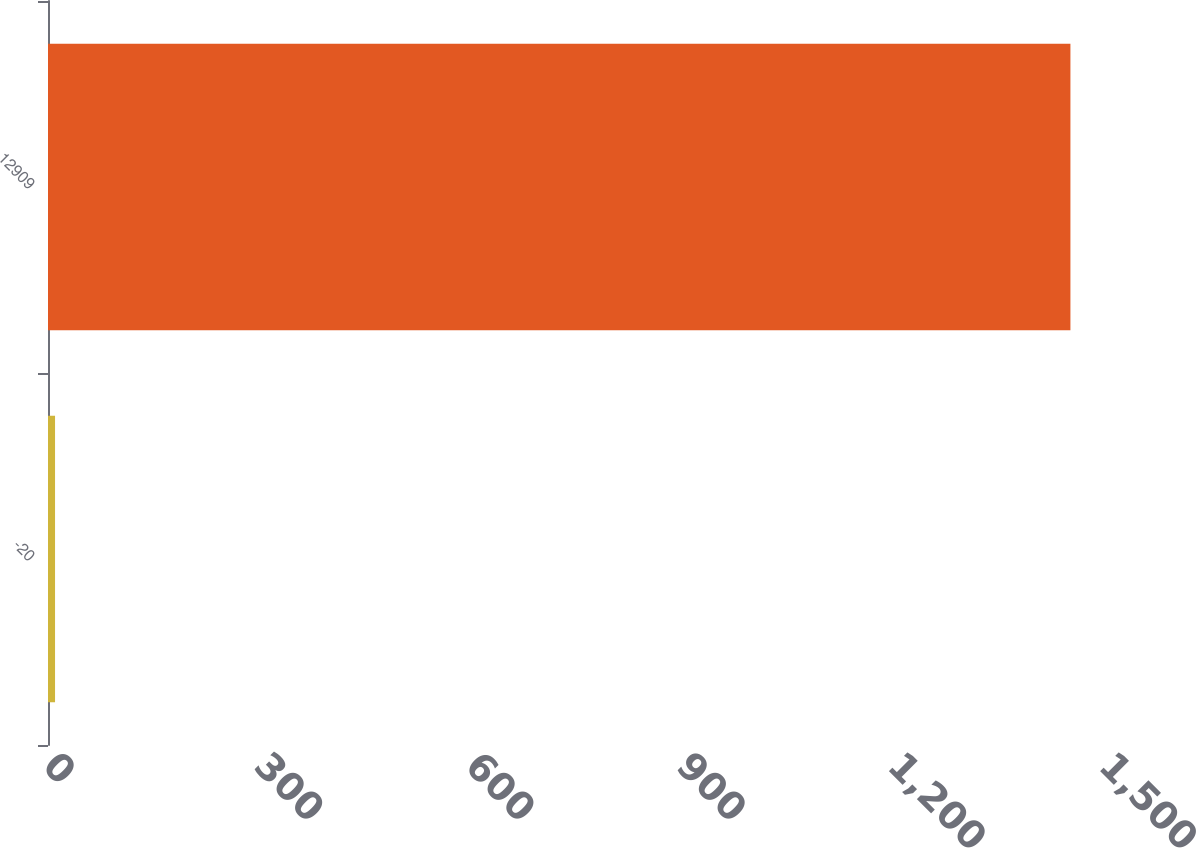Convert chart. <chart><loc_0><loc_0><loc_500><loc_500><bar_chart><fcel>-20<fcel>12909<nl><fcel>10<fcel>1452.3<nl></chart> 